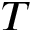Convert formula to latex. <formula><loc_0><loc_0><loc_500><loc_500>T</formula> 